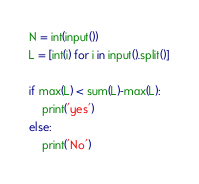Convert code to text. <code><loc_0><loc_0><loc_500><loc_500><_Python_>N = int(input())
L = [int(i) for i in input().split()]

if max(L) < sum(L)-max(L):
    print('yes')
else:
    print('No')
</code> 